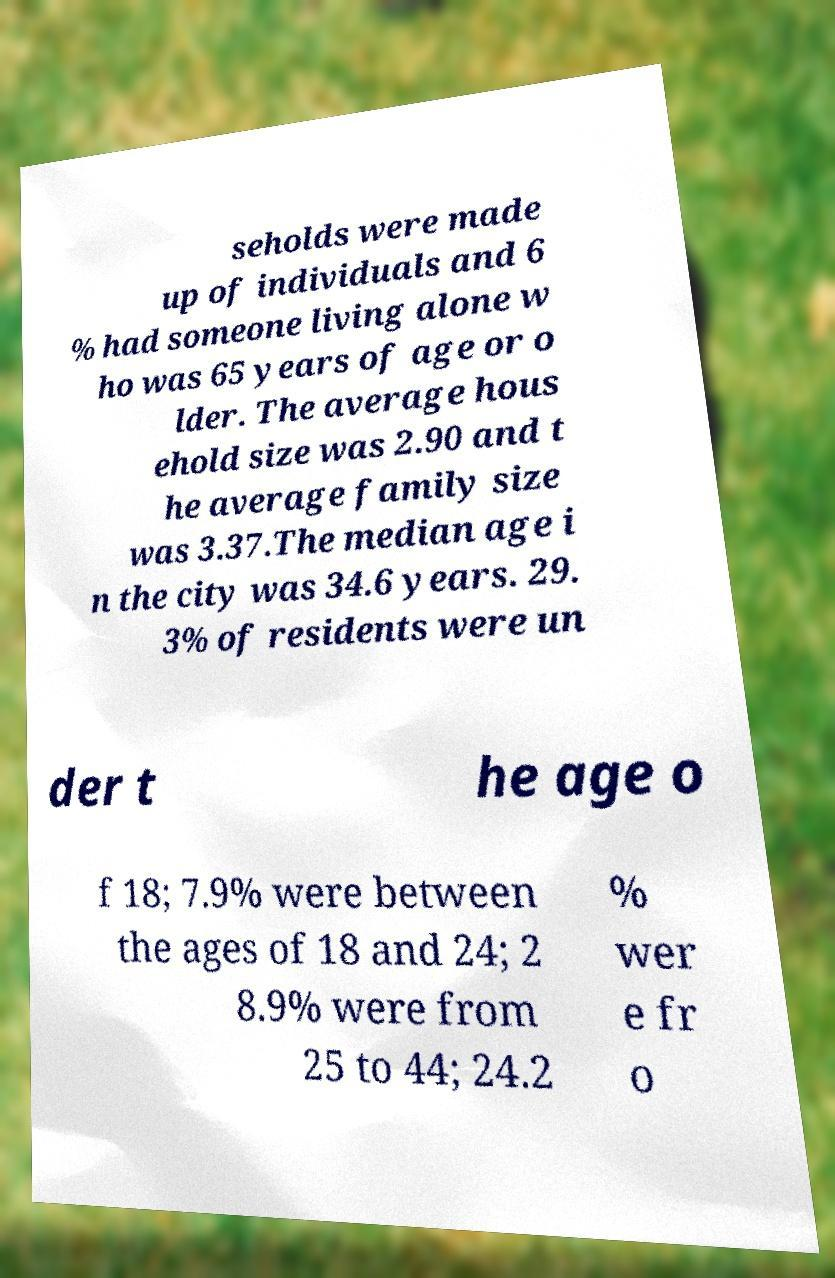Please read and relay the text visible in this image. What does it say? seholds were made up of individuals and 6 % had someone living alone w ho was 65 years of age or o lder. The average hous ehold size was 2.90 and t he average family size was 3.37.The median age i n the city was 34.6 years. 29. 3% of residents were un der t he age o f 18; 7.9% were between the ages of 18 and 24; 2 8.9% were from 25 to 44; 24.2 % wer e fr o 